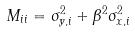Convert formula to latex. <formula><loc_0><loc_0><loc_500><loc_500>M _ { i i } = \sigma _ { y , i } ^ { 2 } + \beta ^ { 2 } \sigma _ { x , i } ^ { 2 }</formula> 